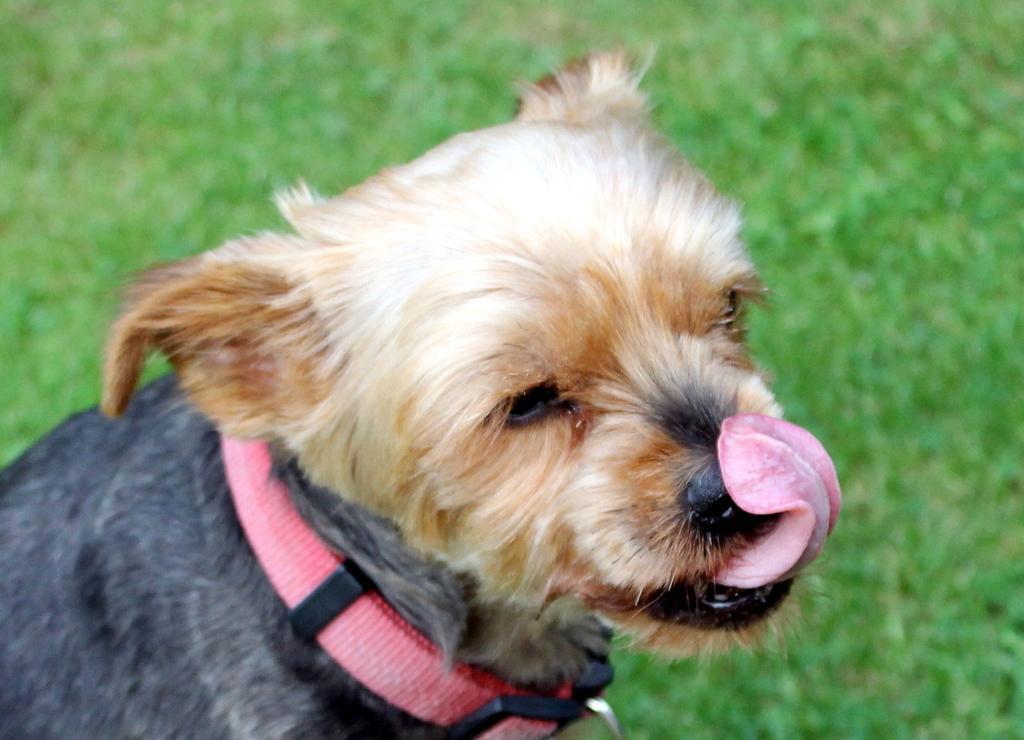Can you describe this image briefly? In this image I can see a dog, there is a belt around its neck and there is the grass in this image. 